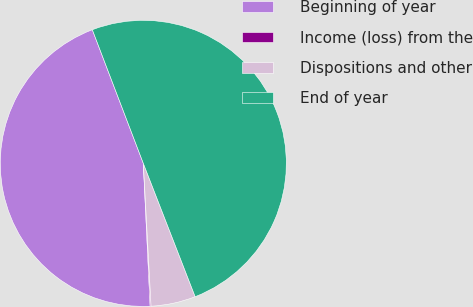Convert chart to OTSL. <chart><loc_0><loc_0><loc_500><loc_500><pie_chart><fcel>Beginning of year<fcel>Income (loss) from the<fcel>Dispositions and other<fcel>End of year<nl><fcel>44.96%<fcel>0.1%<fcel>5.04%<fcel>49.9%<nl></chart> 